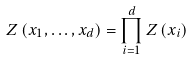Convert formula to latex. <formula><loc_0><loc_0><loc_500><loc_500>Z \left ( x _ { 1 } , \dots , x _ { d } \right ) = \prod _ { i = 1 } ^ { d } Z \left ( x _ { i } \right )</formula> 